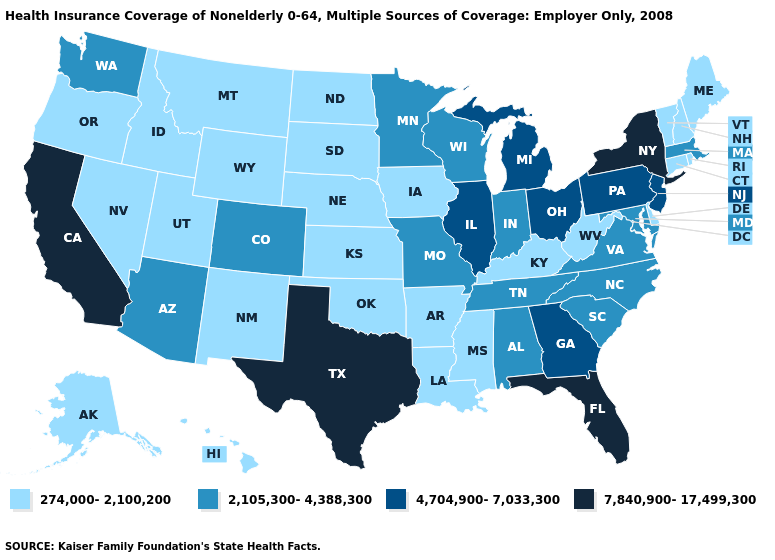Among the states that border Arkansas , which have the highest value?
Give a very brief answer. Texas. Which states have the highest value in the USA?
Answer briefly. California, Florida, New York, Texas. Name the states that have a value in the range 2,105,300-4,388,300?
Keep it brief. Alabama, Arizona, Colorado, Indiana, Maryland, Massachusetts, Minnesota, Missouri, North Carolina, South Carolina, Tennessee, Virginia, Washington, Wisconsin. Name the states that have a value in the range 274,000-2,100,200?
Be succinct. Alaska, Arkansas, Connecticut, Delaware, Hawaii, Idaho, Iowa, Kansas, Kentucky, Louisiana, Maine, Mississippi, Montana, Nebraska, Nevada, New Hampshire, New Mexico, North Dakota, Oklahoma, Oregon, Rhode Island, South Dakota, Utah, Vermont, West Virginia, Wyoming. Name the states that have a value in the range 7,840,900-17,499,300?
Concise answer only. California, Florida, New York, Texas. Does California have the lowest value in the USA?
Keep it brief. No. Among the states that border Alabama , which have the lowest value?
Answer briefly. Mississippi. Among the states that border Texas , which have the lowest value?
Give a very brief answer. Arkansas, Louisiana, New Mexico, Oklahoma. Name the states that have a value in the range 7,840,900-17,499,300?
Give a very brief answer. California, Florida, New York, Texas. What is the value of Wisconsin?
Keep it brief. 2,105,300-4,388,300. Among the states that border Oklahoma , does Texas have the highest value?
Short answer required. Yes. Name the states that have a value in the range 274,000-2,100,200?
Keep it brief. Alaska, Arkansas, Connecticut, Delaware, Hawaii, Idaho, Iowa, Kansas, Kentucky, Louisiana, Maine, Mississippi, Montana, Nebraska, Nevada, New Hampshire, New Mexico, North Dakota, Oklahoma, Oregon, Rhode Island, South Dakota, Utah, Vermont, West Virginia, Wyoming. Does Vermont have the lowest value in the Northeast?
Give a very brief answer. Yes. Does New Jersey have the lowest value in the Northeast?
Concise answer only. No. Does the map have missing data?
Be succinct. No. 